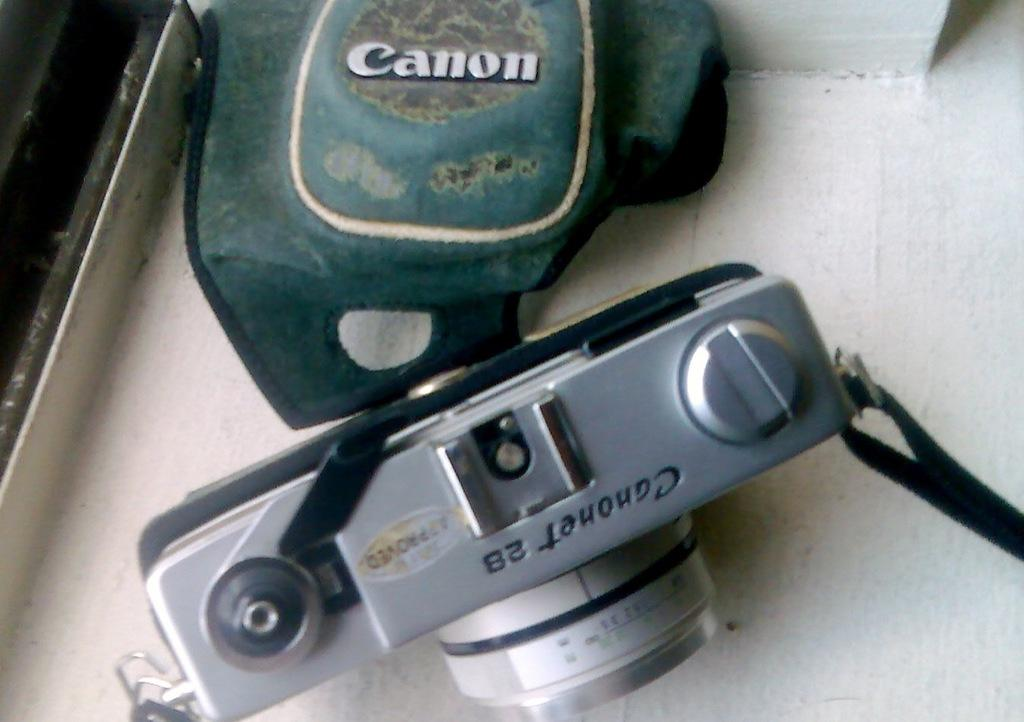What is the main subject of the image? The main subject of the image is a camera. What else can be seen in the image besides the camera? There is a pouch in the image. What color is the background of the image? The background of the image is white. Can you describe the object on the left side top of the image? Unfortunately, the provided facts do not give enough information to describe the object on the left side top of the image. How does the camera improve the acoustics in the image? The camera does not improve the acoustics in the image, as it is a visual device and not related to sound. Is there a parcel being delivered in the image? There is no mention of a parcel in the provided facts, so it cannot be determined from the image. 